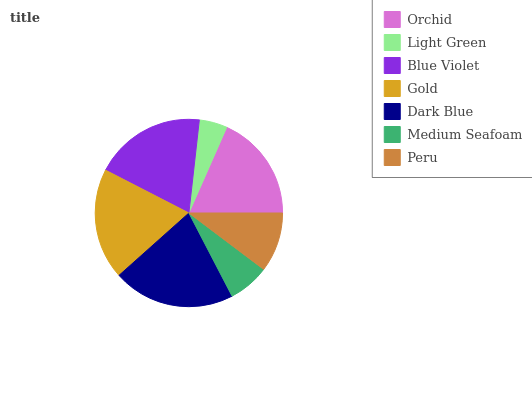Is Light Green the minimum?
Answer yes or no. Yes. Is Dark Blue the maximum?
Answer yes or no. Yes. Is Blue Violet the minimum?
Answer yes or no. No. Is Blue Violet the maximum?
Answer yes or no. No. Is Blue Violet greater than Light Green?
Answer yes or no. Yes. Is Light Green less than Blue Violet?
Answer yes or no. Yes. Is Light Green greater than Blue Violet?
Answer yes or no. No. Is Blue Violet less than Light Green?
Answer yes or no. No. Is Orchid the high median?
Answer yes or no. Yes. Is Orchid the low median?
Answer yes or no. Yes. Is Light Green the high median?
Answer yes or no. No. Is Blue Violet the low median?
Answer yes or no. No. 